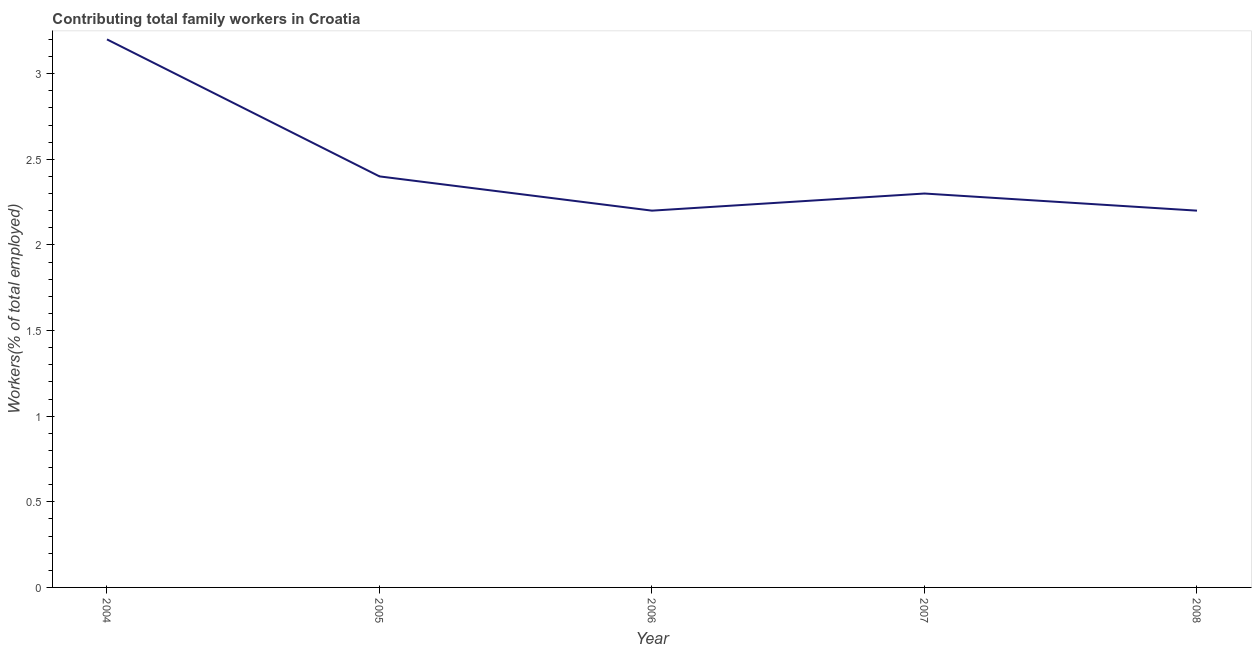What is the contributing family workers in 2005?
Your answer should be very brief. 2.4. Across all years, what is the maximum contributing family workers?
Offer a terse response. 3.2. Across all years, what is the minimum contributing family workers?
Keep it short and to the point. 2.2. In which year was the contributing family workers maximum?
Your response must be concise. 2004. In which year was the contributing family workers minimum?
Provide a succinct answer. 2006. What is the sum of the contributing family workers?
Your answer should be compact. 12.3. What is the difference between the contributing family workers in 2005 and 2007?
Offer a very short reply. 0.1. What is the average contributing family workers per year?
Offer a terse response. 2.46. What is the median contributing family workers?
Offer a terse response. 2.3. In how many years, is the contributing family workers greater than 0.30000000000000004 %?
Your answer should be very brief. 5. What is the ratio of the contributing family workers in 2006 to that in 2008?
Give a very brief answer. 1. Is the difference between the contributing family workers in 2005 and 2007 greater than the difference between any two years?
Provide a succinct answer. No. What is the difference between the highest and the second highest contributing family workers?
Make the answer very short. 0.8. Does the contributing family workers monotonically increase over the years?
Offer a very short reply. No. How many lines are there?
Give a very brief answer. 1. How many years are there in the graph?
Ensure brevity in your answer.  5. What is the difference between two consecutive major ticks on the Y-axis?
Make the answer very short. 0.5. Does the graph contain grids?
Provide a succinct answer. No. What is the title of the graph?
Your response must be concise. Contributing total family workers in Croatia. What is the label or title of the Y-axis?
Keep it short and to the point. Workers(% of total employed). What is the Workers(% of total employed) of 2004?
Keep it short and to the point. 3.2. What is the Workers(% of total employed) in 2005?
Your answer should be compact. 2.4. What is the Workers(% of total employed) in 2006?
Make the answer very short. 2.2. What is the Workers(% of total employed) of 2007?
Your answer should be compact. 2.3. What is the Workers(% of total employed) in 2008?
Provide a short and direct response. 2.2. What is the difference between the Workers(% of total employed) in 2004 and 2005?
Your answer should be very brief. 0.8. What is the difference between the Workers(% of total employed) in 2004 and 2007?
Keep it short and to the point. 0.9. What is the difference between the Workers(% of total employed) in 2004 and 2008?
Your response must be concise. 1. What is the difference between the Workers(% of total employed) in 2005 and 2007?
Your answer should be compact. 0.1. What is the difference between the Workers(% of total employed) in 2005 and 2008?
Provide a succinct answer. 0.2. What is the ratio of the Workers(% of total employed) in 2004 to that in 2005?
Offer a very short reply. 1.33. What is the ratio of the Workers(% of total employed) in 2004 to that in 2006?
Your response must be concise. 1.46. What is the ratio of the Workers(% of total employed) in 2004 to that in 2007?
Provide a short and direct response. 1.39. What is the ratio of the Workers(% of total employed) in 2004 to that in 2008?
Your response must be concise. 1.46. What is the ratio of the Workers(% of total employed) in 2005 to that in 2006?
Your response must be concise. 1.09. What is the ratio of the Workers(% of total employed) in 2005 to that in 2007?
Keep it short and to the point. 1.04. What is the ratio of the Workers(% of total employed) in 2005 to that in 2008?
Offer a very short reply. 1.09. What is the ratio of the Workers(% of total employed) in 2007 to that in 2008?
Your response must be concise. 1.04. 